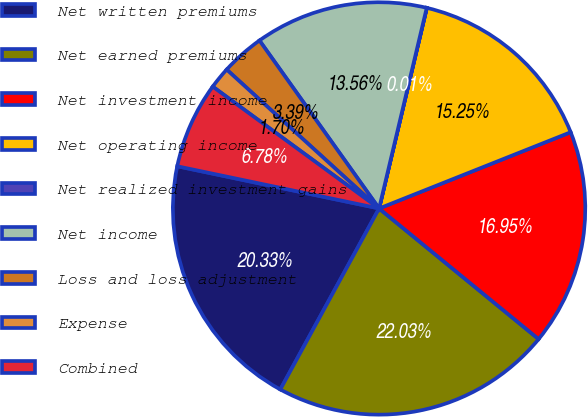Convert chart. <chart><loc_0><loc_0><loc_500><loc_500><pie_chart><fcel>Net written premiums<fcel>Net earned premiums<fcel>Net investment income<fcel>Net operating income<fcel>Net realized investment gains<fcel>Net income<fcel>Loss and loss adjustment<fcel>Expense<fcel>Combined<nl><fcel>20.33%<fcel>22.03%<fcel>16.95%<fcel>15.25%<fcel>0.01%<fcel>13.56%<fcel>3.39%<fcel>1.7%<fcel>6.78%<nl></chart> 